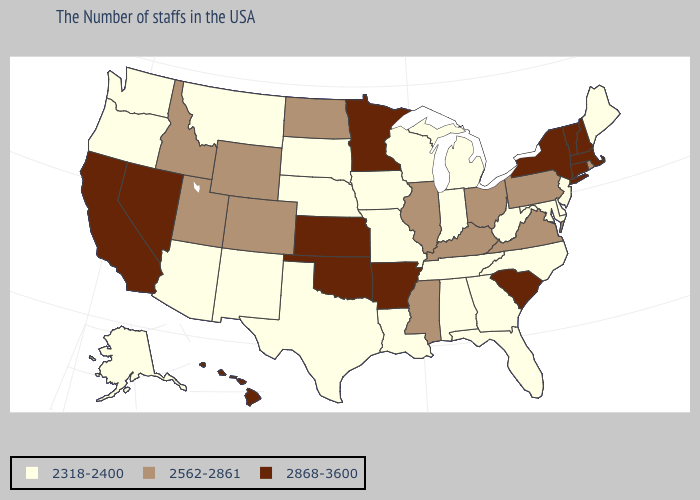Does Iowa have the lowest value in the USA?
Answer briefly. Yes. What is the lowest value in the USA?
Give a very brief answer. 2318-2400. Is the legend a continuous bar?
Quick response, please. No. Among the states that border Florida , which have the highest value?
Give a very brief answer. Georgia, Alabama. What is the highest value in states that border Idaho?
Write a very short answer. 2868-3600. What is the lowest value in states that border Vermont?
Write a very short answer. 2868-3600. Is the legend a continuous bar?
Short answer required. No. Name the states that have a value in the range 2318-2400?
Quick response, please. Maine, New Jersey, Delaware, Maryland, North Carolina, West Virginia, Florida, Georgia, Michigan, Indiana, Alabama, Tennessee, Wisconsin, Louisiana, Missouri, Iowa, Nebraska, Texas, South Dakota, New Mexico, Montana, Arizona, Washington, Oregon, Alaska. What is the value of Nebraska?
Give a very brief answer. 2318-2400. Name the states that have a value in the range 2868-3600?
Short answer required. Massachusetts, New Hampshire, Vermont, Connecticut, New York, South Carolina, Arkansas, Minnesota, Kansas, Oklahoma, Nevada, California, Hawaii. Does the first symbol in the legend represent the smallest category?
Write a very short answer. Yes. Name the states that have a value in the range 2562-2861?
Short answer required. Rhode Island, Pennsylvania, Virginia, Ohio, Kentucky, Illinois, Mississippi, North Dakota, Wyoming, Colorado, Utah, Idaho. How many symbols are there in the legend?
Give a very brief answer. 3. Which states have the highest value in the USA?
Short answer required. Massachusetts, New Hampshire, Vermont, Connecticut, New York, South Carolina, Arkansas, Minnesota, Kansas, Oklahoma, Nevada, California, Hawaii. Does New Jersey have the highest value in the Northeast?
Concise answer only. No. 